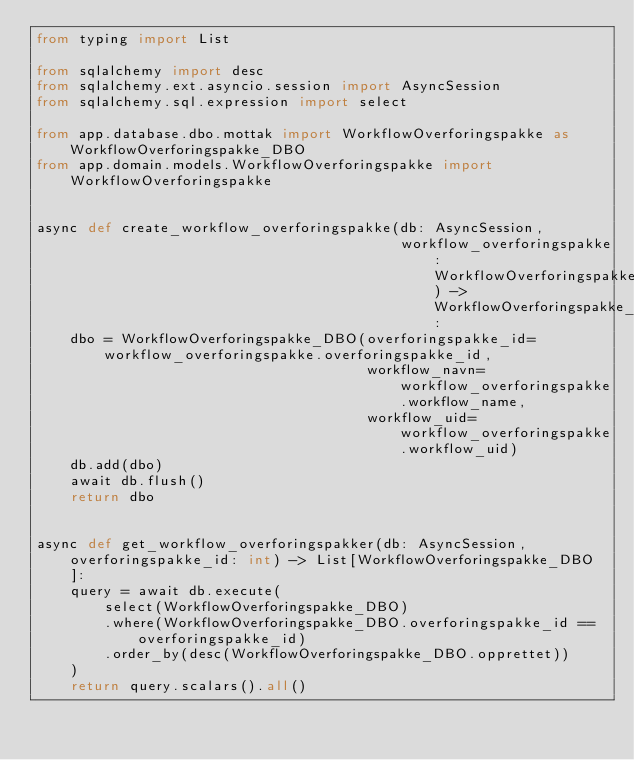Convert code to text. <code><loc_0><loc_0><loc_500><loc_500><_Python_>from typing import List

from sqlalchemy import desc
from sqlalchemy.ext.asyncio.session import AsyncSession
from sqlalchemy.sql.expression import select

from app.database.dbo.mottak import WorkflowOverforingspakke as WorkflowOverforingspakke_DBO
from app.domain.models.WorkflowOverforingspakke import WorkflowOverforingspakke


async def create_workflow_overforingspakke(db: AsyncSession,
                                           workflow_overforingspakke: WorkflowOverforingspakke) -> WorkflowOverforingspakke_DBO:
    dbo = WorkflowOverforingspakke_DBO(overforingspakke_id=workflow_overforingspakke.overforingspakke_id,
                                       workflow_navn=workflow_overforingspakke.workflow_name,
                                       workflow_uid=workflow_overforingspakke.workflow_uid)
    db.add(dbo)
    await db.flush()
    return dbo


async def get_workflow_overforingspakker(db: AsyncSession, overforingspakke_id: int) -> List[WorkflowOverforingspakke_DBO]:
    query = await db.execute(
        select(WorkflowOverforingspakke_DBO)
        .where(WorkflowOverforingspakke_DBO.overforingspakke_id == overforingspakke_id)
        .order_by(desc(WorkflowOverforingspakke_DBO.opprettet))
    )
    return query.scalars().all()
</code> 